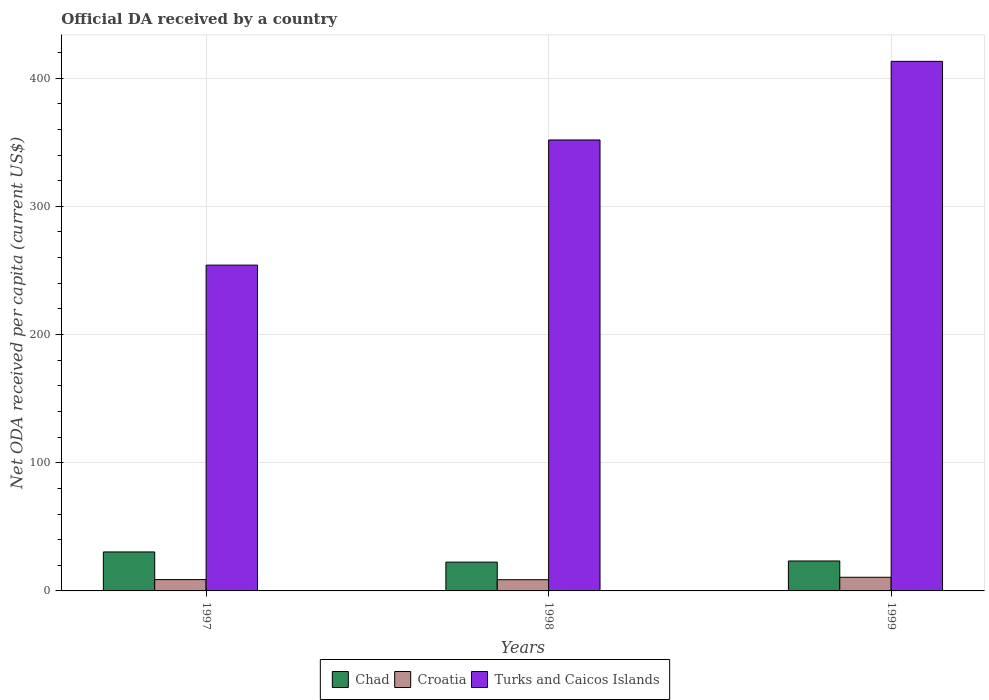How many different coloured bars are there?
Give a very brief answer. 3. How many groups of bars are there?
Offer a terse response. 3. Are the number of bars per tick equal to the number of legend labels?
Your answer should be compact. Yes. Are the number of bars on each tick of the X-axis equal?
Provide a succinct answer. Yes. What is the label of the 1st group of bars from the left?
Give a very brief answer. 1997. In how many cases, is the number of bars for a given year not equal to the number of legend labels?
Provide a short and direct response. 0. What is the ODA received in in Croatia in 1999?
Your response must be concise. 10.64. Across all years, what is the maximum ODA received in in Chad?
Your response must be concise. 30.41. Across all years, what is the minimum ODA received in in Croatia?
Keep it short and to the point. 8.75. In which year was the ODA received in in Chad maximum?
Your answer should be compact. 1997. In which year was the ODA received in in Turks and Caicos Islands minimum?
Offer a terse response. 1997. What is the total ODA received in in Chad in the graph?
Ensure brevity in your answer.  76.23. What is the difference between the ODA received in in Croatia in 1997 and that in 1999?
Your answer should be very brief. -1.82. What is the difference between the ODA received in in Croatia in 1998 and the ODA received in in Turks and Caicos Islands in 1999?
Your response must be concise. -404.33. What is the average ODA received in in Croatia per year?
Offer a terse response. 9.41. In the year 1997, what is the difference between the ODA received in in Croatia and ODA received in in Turks and Caicos Islands?
Make the answer very short. -245.3. What is the ratio of the ODA received in in Turks and Caicos Islands in 1997 to that in 1998?
Provide a succinct answer. 0.72. Is the ODA received in in Chad in 1997 less than that in 1999?
Offer a very short reply. No. What is the difference between the highest and the second highest ODA received in in Croatia?
Offer a very short reply. 1.82. What is the difference between the highest and the lowest ODA received in in Croatia?
Make the answer very short. 1.89. Is the sum of the ODA received in in Turks and Caicos Islands in 1998 and 1999 greater than the maximum ODA received in in Croatia across all years?
Ensure brevity in your answer.  Yes. What does the 1st bar from the left in 1999 represents?
Provide a succinct answer. Chad. What does the 1st bar from the right in 1999 represents?
Offer a very short reply. Turks and Caicos Islands. Does the graph contain any zero values?
Your answer should be compact. No. Does the graph contain grids?
Your answer should be very brief. Yes. Where does the legend appear in the graph?
Your answer should be compact. Bottom center. How many legend labels are there?
Your answer should be compact. 3. What is the title of the graph?
Your response must be concise. Official DA received by a country. What is the label or title of the Y-axis?
Offer a terse response. Net ODA received per capita (current US$). What is the Net ODA received per capita (current US$) of Chad in 1997?
Offer a very short reply. 30.41. What is the Net ODA received per capita (current US$) of Croatia in 1997?
Your answer should be compact. 8.83. What is the Net ODA received per capita (current US$) in Turks and Caicos Islands in 1997?
Your answer should be very brief. 254.13. What is the Net ODA received per capita (current US$) of Chad in 1998?
Offer a terse response. 22.47. What is the Net ODA received per capita (current US$) in Croatia in 1998?
Offer a very short reply. 8.75. What is the Net ODA received per capita (current US$) of Turks and Caicos Islands in 1998?
Keep it short and to the point. 351.76. What is the Net ODA received per capita (current US$) in Chad in 1999?
Make the answer very short. 23.36. What is the Net ODA received per capita (current US$) of Croatia in 1999?
Your answer should be very brief. 10.64. What is the Net ODA received per capita (current US$) in Turks and Caicos Islands in 1999?
Offer a terse response. 413.08. Across all years, what is the maximum Net ODA received per capita (current US$) in Chad?
Offer a very short reply. 30.41. Across all years, what is the maximum Net ODA received per capita (current US$) in Croatia?
Give a very brief answer. 10.64. Across all years, what is the maximum Net ODA received per capita (current US$) in Turks and Caicos Islands?
Your response must be concise. 413.08. Across all years, what is the minimum Net ODA received per capita (current US$) in Chad?
Offer a terse response. 22.47. Across all years, what is the minimum Net ODA received per capita (current US$) in Croatia?
Ensure brevity in your answer.  8.75. Across all years, what is the minimum Net ODA received per capita (current US$) of Turks and Caicos Islands?
Offer a terse response. 254.13. What is the total Net ODA received per capita (current US$) of Chad in the graph?
Your response must be concise. 76.23. What is the total Net ODA received per capita (current US$) of Croatia in the graph?
Offer a terse response. 28.22. What is the total Net ODA received per capita (current US$) in Turks and Caicos Islands in the graph?
Your answer should be compact. 1018.96. What is the difference between the Net ODA received per capita (current US$) of Chad in 1997 and that in 1998?
Give a very brief answer. 7.94. What is the difference between the Net ODA received per capita (current US$) of Croatia in 1997 and that in 1998?
Offer a very short reply. 0.08. What is the difference between the Net ODA received per capita (current US$) of Turks and Caicos Islands in 1997 and that in 1998?
Give a very brief answer. -97.63. What is the difference between the Net ODA received per capita (current US$) of Chad in 1997 and that in 1999?
Offer a terse response. 7.05. What is the difference between the Net ODA received per capita (current US$) in Croatia in 1997 and that in 1999?
Keep it short and to the point. -1.82. What is the difference between the Net ODA received per capita (current US$) of Turks and Caicos Islands in 1997 and that in 1999?
Keep it short and to the point. -158.95. What is the difference between the Net ODA received per capita (current US$) in Chad in 1998 and that in 1999?
Your answer should be compact. -0.89. What is the difference between the Net ODA received per capita (current US$) in Croatia in 1998 and that in 1999?
Make the answer very short. -1.89. What is the difference between the Net ODA received per capita (current US$) of Turks and Caicos Islands in 1998 and that in 1999?
Your response must be concise. -61.32. What is the difference between the Net ODA received per capita (current US$) of Chad in 1997 and the Net ODA received per capita (current US$) of Croatia in 1998?
Provide a succinct answer. 21.66. What is the difference between the Net ODA received per capita (current US$) of Chad in 1997 and the Net ODA received per capita (current US$) of Turks and Caicos Islands in 1998?
Provide a succinct answer. -321.35. What is the difference between the Net ODA received per capita (current US$) in Croatia in 1997 and the Net ODA received per capita (current US$) in Turks and Caicos Islands in 1998?
Offer a very short reply. -342.93. What is the difference between the Net ODA received per capita (current US$) of Chad in 1997 and the Net ODA received per capita (current US$) of Croatia in 1999?
Offer a very short reply. 19.76. What is the difference between the Net ODA received per capita (current US$) in Chad in 1997 and the Net ODA received per capita (current US$) in Turks and Caicos Islands in 1999?
Give a very brief answer. -382.67. What is the difference between the Net ODA received per capita (current US$) in Croatia in 1997 and the Net ODA received per capita (current US$) in Turks and Caicos Islands in 1999?
Offer a very short reply. -404.25. What is the difference between the Net ODA received per capita (current US$) of Chad in 1998 and the Net ODA received per capita (current US$) of Croatia in 1999?
Provide a succinct answer. 11.83. What is the difference between the Net ODA received per capita (current US$) of Chad in 1998 and the Net ODA received per capita (current US$) of Turks and Caicos Islands in 1999?
Make the answer very short. -390.61. What is the difference between the Net ODA received per capita (current US$) in Croatia in 1998 and the Net ODA received per capita (current US$) in Turks and Caicos Islands in 1999?
Provide a short and direct response. -404.33. What is the average Net ODA received per capita (current US$) of Chad per year?
Provide a short and direct response. 25.41. What is the average Net ODA received per capita (current US$) in Croatia per year?
Keep it short and to the point. 9.41. What is the average Net ODA received per capita (current US$) in Turks and Caicos Islands per year?
Offer a terse response. 339.65. In the year 1997, what is the difference between the Net ODA received per capita (current US$) of Chad and Net ODA received per capita (current US$) of Croatia?
Offer a very short reply. 21.58. In the year 1997, what is the difference between the Net ODA received per capita (current US$) of Chad and Net ODA received per capita (current US$) of Turks and Caicos Islands?
Your answer should be very brief. -223.72. In the year 1997, what is the difference between the Net ODA received per capita (current US$) of Croatia and Net ODA received per capita (current US$) of Turks and Caicos Islands?
Give a very brief answer. -245.3. In the year 1998, what is the difference between the Net ODA received per capita (current US$) in Chad and Net ODA received per capita (current US$) in Croatia?
Offer a terse response. 13.72. In the year 1998, what is the difference between the Net ODA received per capita (current US$) of Chad and Net ODA received per capita (current US$) of Turks and Caicos Islands?
Provide a succinct answer. -329.29. In the year 1998, what is the difference between the Net ODA received per capita (current US$) of Croatia and Net ODA received per capita (current US$) of Turks and Caicos Islands?
Provide a short and direct response. -343.01. In the year 1999, what is the difference between the Net ODA received per capita (current US$) in Chad and Net ODA received per capita (current US$) in Croatia?
Your answer should be compact. 12.71. In the year 1999, what is the difference between the Net ODA received per capita (current US$) of Chad and Net ODA received per capita (current US$) of Turks and Caicos Islands?
Offer a terse response. -389.72. In the year 1999, what is the difference between the Net ODA received per capita (current US$) in Croatia and Net ODA received per capita (current US$) in Turks and Caicos Islands?
Your answer should be compact. -402.43. What is the ratio of the Net ODA received per capita (current US$) of Chad in 1997 to that in 1998?
Keep it short and to the point. 1.35. What is the ratio of the Net ODA received per capita (current US$) of Croatia in 1997 to that in 1998?
Keep it short and to the point. 1.01. What is the ratio of the Net ODA received per capita (current US$) in Turks and Caicos Islands in 1997 to that in 1998?
Make the answer very short. 0.72. What is the ratio of the Net ODA received per capita (current US$) in Chad in 1997 to that in 1999?
Keep it short and to the point. 1.3. What is the ratio of the Net ODA received per capita (current US$) in Croatia in 1997 to that in 1999?
Keep it short and to the point. 0.83. What is the ratio of the Net ODA received per capita (current US$) of Turks and Caicos Islands in 1997 to that in 1999?
Make the answer very short. 0.62. What is the ratio of the Net ODA received per capita (current US$) of Croatia in 1998 to that in 1999?
Your answer should be compact. 0.82. What is the ratio of the Net ODA received per capita (current US$) in Turks and Caicos Islands in 1998 to that in 1999?
Your response must be concise. 0.85. What is the difference between the highest and the second highest Net ODA received per capita (current US$) of Chad?
Offer a terse response. 7.05. What is the difference between the highest and the second highest Net ODA received per capita (current US$) in Croatia?
Offer a terse response. 1.82. What is the difference between the highest and the second highest Net ODA received per capita (current US$) in Turks and Caicos Islands?
Ensure brevity in your answer.  61.32. What is the difference between the highest and the lowest Net ODA received per capita (current US$) of Chad?
Provide a short and direct response. 7.94. What is the difference between the highest and the lowest Net ODA received per capita (current US$) of Croatia?
Your answer should be very brief. 1.89. What is the difference between the highest and the lowest Net ODA received per capita (current US$) in Turks and Caicos Islands?
Your answer should be very brief. 158.95. 